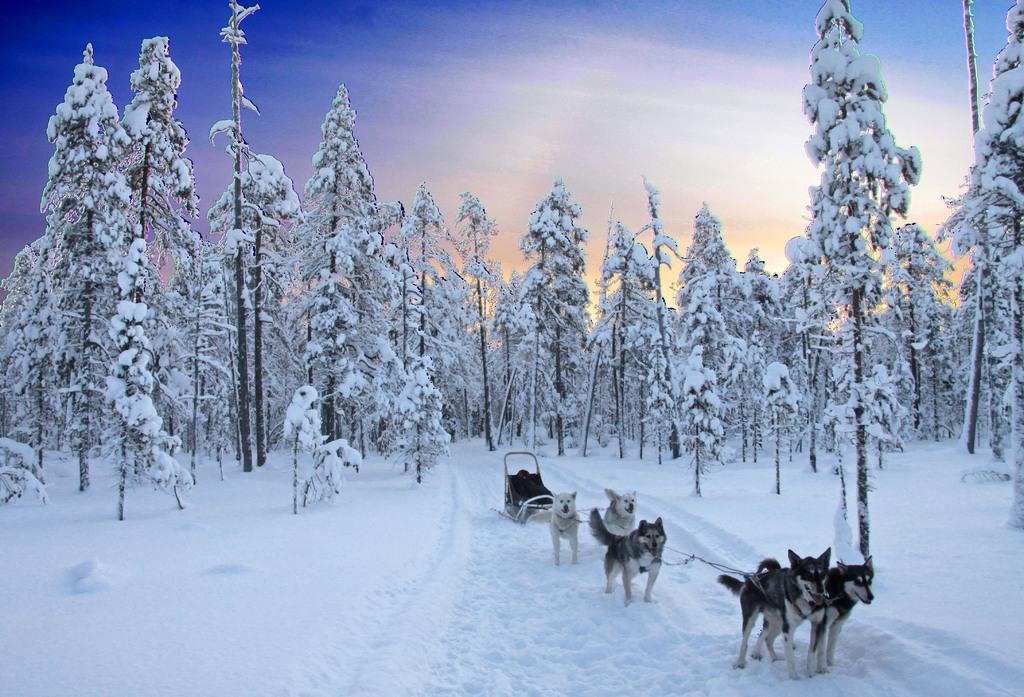Please provide a concise description of this image. In the picture we can see some dogs which are running in snow, there are some trees and top of the picture there is clear sky. 